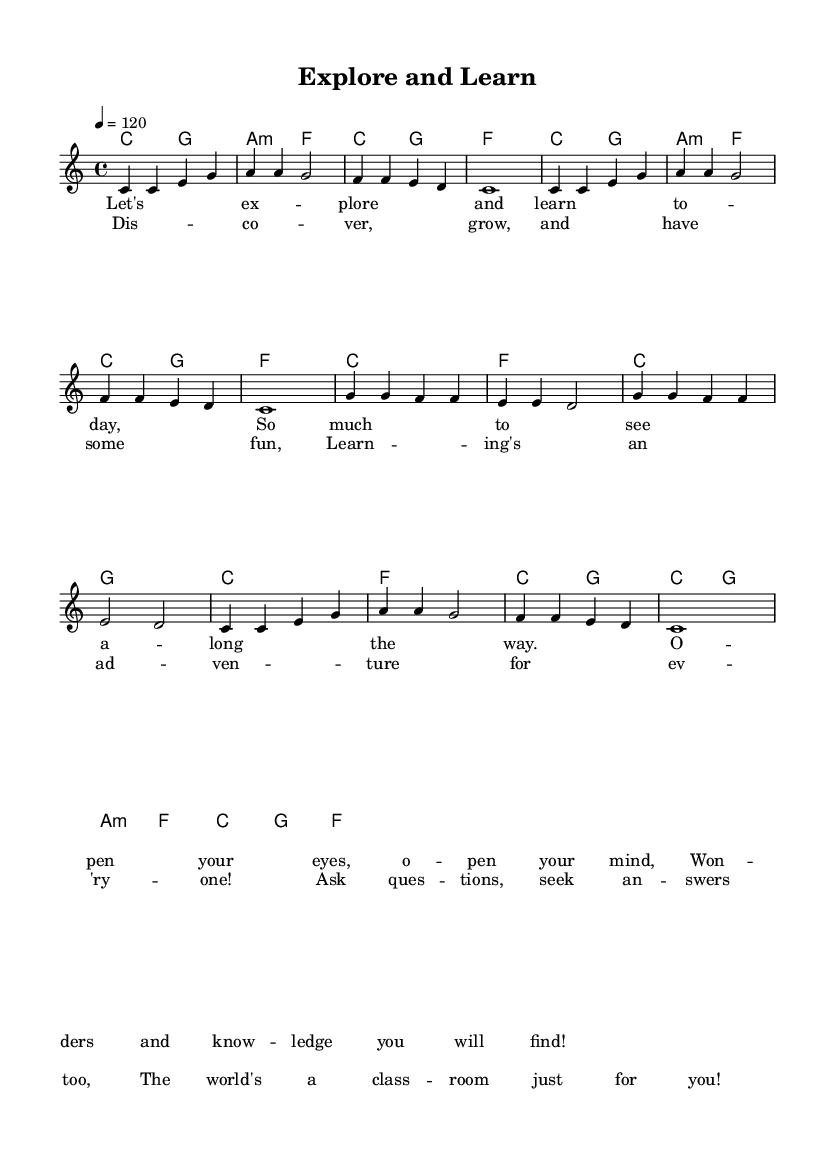What is the key signature of this music? The key signature is indicated at the beginning of the score, which shows no sharps or flats. This corresponds to C major.
Answer: C major What is the time signature of this piece? The time signature is found at the start of the score and is shown as 4/4, indicating four beats per measure.
Answer: 4/4 What is the tempo marking? The tempo is specified in the score using the text "4 = 120", meaning there are 120 beats per minute.
Answer: 120 How many measures are in the melody section? By counting the number of vertical lines representing the ends of measures in the melody part, we find there are 8 measures.
Answer: 8 What type of chords are used in the harmonies? The chord mode section lists the chords, including major and minor types, which indicate the use of both C major and A minor chords.
Answer: Major and minor What is the first lyric of the song? The first line of the verse in the lyric section starts with "Let's explore", which indicates the theme of discovery.
Answer: Let's explore How does the chorus emphasize learning? The chorus mentions "learning's an adventure", which signifies that the song focuses on the fun and engaging aspects of learning.
Answer: Learning's an adventure 